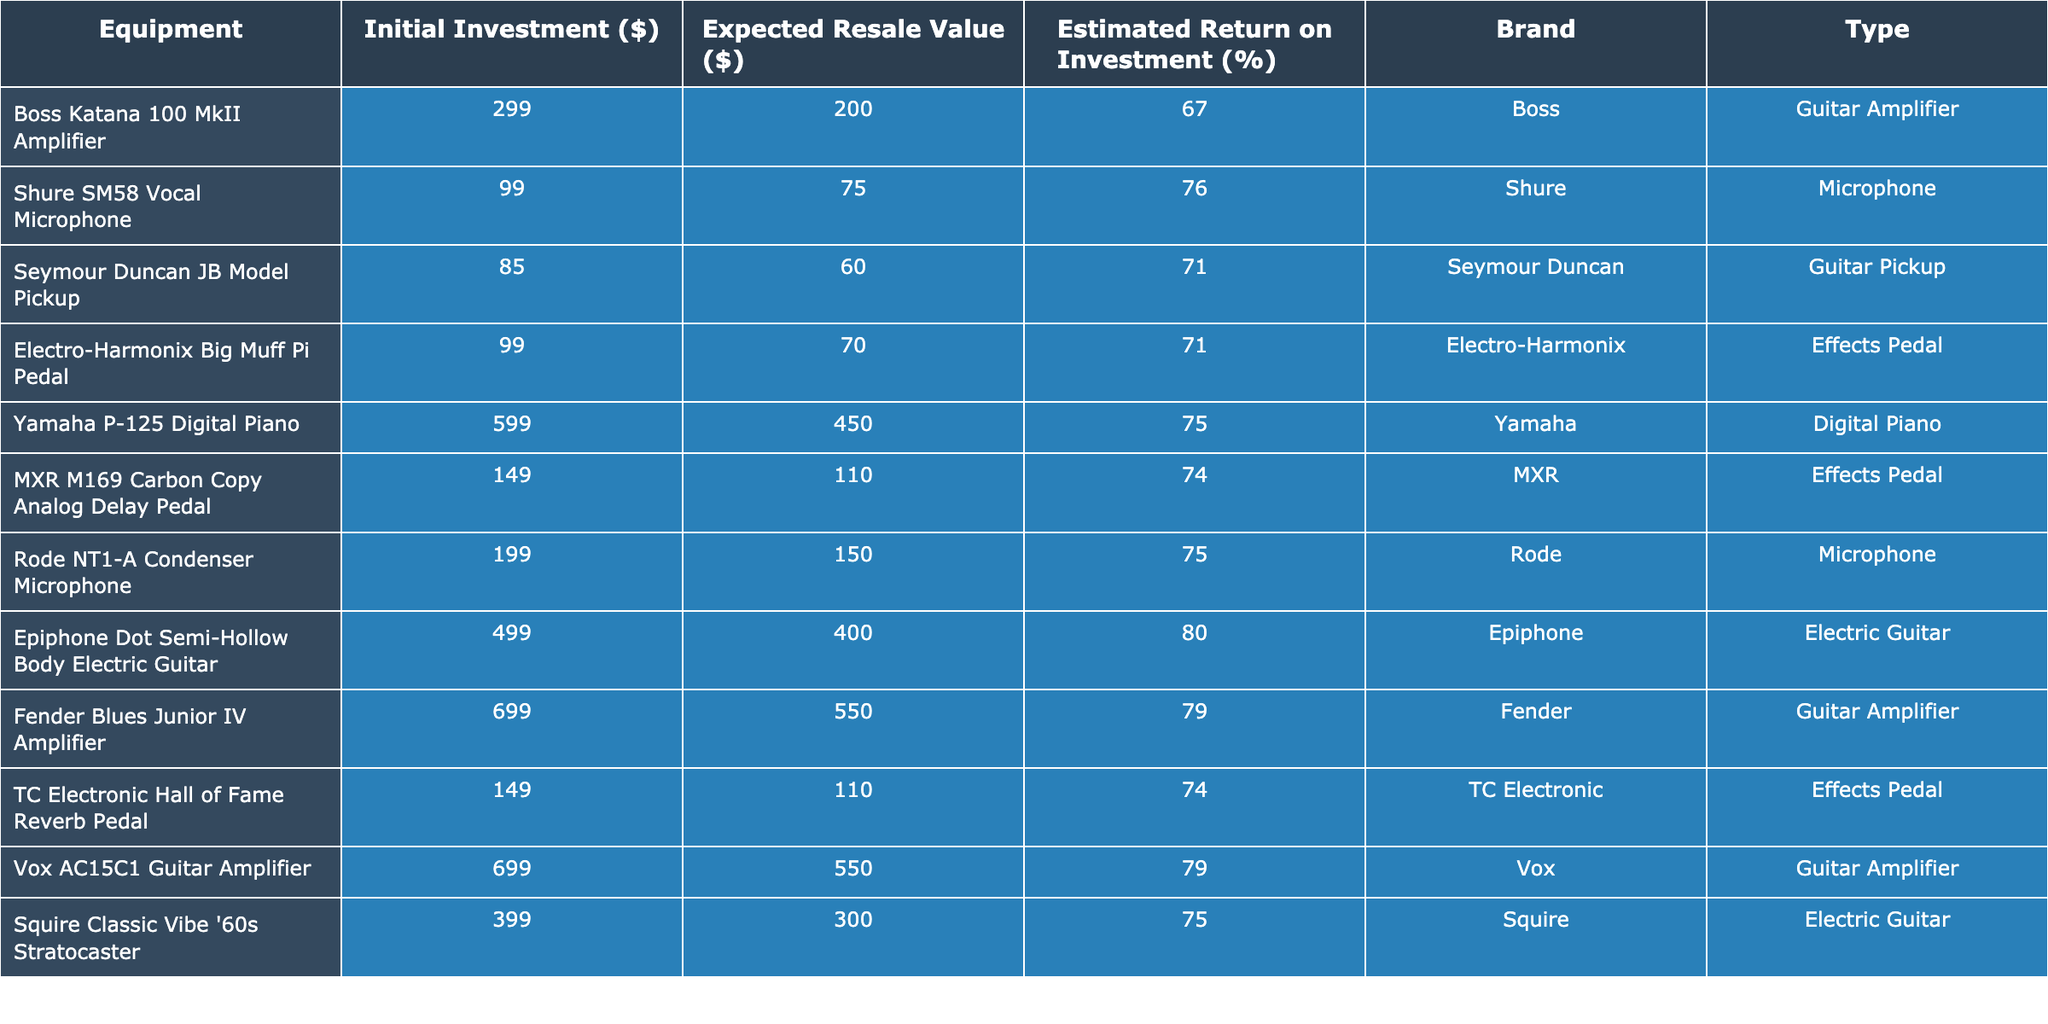What is the expected resale value of the Boss Katana 100 MkII Amplifier? The expected resale value of the Boss Katana 100 MkII Amplifier is listed in the table under the "Expected Resale Value ($)" column. It shows the value of 200.
Answer: 200 Which equipment has the highest estimated return on investment? The table lists the estimated returns on investment for each piece of equipment. By comparing these values, the Epiphone Dot Semi-Hollow Body Electric Guitar has the highest estimated return at 80%.
Answer: 80% What is the total initial investment of the effects pedals listed? The initial investments for the effects pedals are 99, 149, and 149. Adding these together gives: 99 + 149 + 149 = 397.
Answer: 397 Is the Shure SM58 Vocal Microphone a microphone? The Shure SM58 Vocal Microphone is identified in the "Type" column of the table as a "Microphone," confirming that it is indeed a microphone.
Answer: Yes What is the average expected resale value of all the guitar amplifiers listed? The expected resale values for the amplifiers are 200 (Boss), 550 (Fender), and 550 (Vox). Their total is 200 + 550 + 550 = 1300, and dividing by the number of amplifiers (3) gives an average of 1300 / 3 ≈ 433.33.
Answer: 433.33 Which equipment type has the lowest expected resale value? By reviewing the "Expected Resale Value ($)" column, the equipment with the lowest resale value is the Seymour Duncan JB Model Pickup, with a value of 60, categorized under "Guitar Pickup."
Answer: Guitar Pickup How much more is the initial investment of the Fender Blues Junior IV Amplifier compared to the Shure SM58 Vocal Microphone? The initial investment for the Fender Blues Junior IV Amplifier is 699 and for the Shure SM58 Vocal Microphone it is 99. The difference is 699 - 99 = 600.
Answer: 600 What percentage of the initial investment do you expect to recover from selling the TC Electronic Hall of Fame Reverb Pedal? The expected resale value for the TC Electronic Hall of Fame Reverb Pedal is 110. The initial investment is 149. The estimated return on investment percentage is calculated as (110 / 149) * 100 = 73.82%.
Answer: 73.82% Is it true that the Yamaha P-125 Digital Piano has an initial investment lower than 600? The initial investment for the Yamaha P-125 Digital Piano is listed as 599, which is lower than 600, making the statement true.
Answer: True What is the total estimated return on investment of the microphones listed? The estimated returns for the microphones are 76 for the Shure SM58 and 75 for the Rode NT1-A. Adding these together gives: 76 + 75 = 151.
Answer: 151 